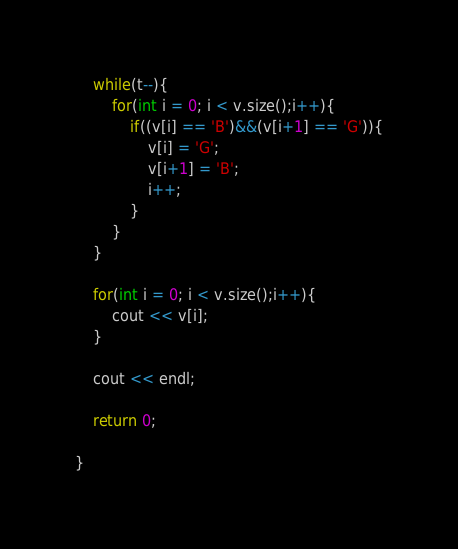Convert code to text. <code><loc_0><loc_0><loc_500><loc_500><_C++_>
    while(t--){
        for(int i = 0; i < v.size();i++){
            if((v[i] == 'B')&&(v[i+1] == 'G')){
                v[i] = 'G';
                v[i+1] = 'B';
                i++;
            }
        }
    }

    for(int i = 0; i < v.size();i++){
        cout << v[i];
    }

    cout << endl;

    return 0;

}
</code> 